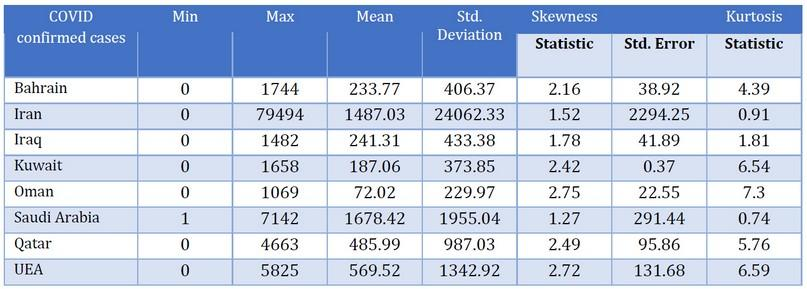Give some essential details in this illustration. Saudi Arabia has a minimum number of 1, making it the country with the smallest population. The country with the second highest Kurtosis statistic number is Kuwait. The country with the second highest number of cases is Saudi Arabia. 